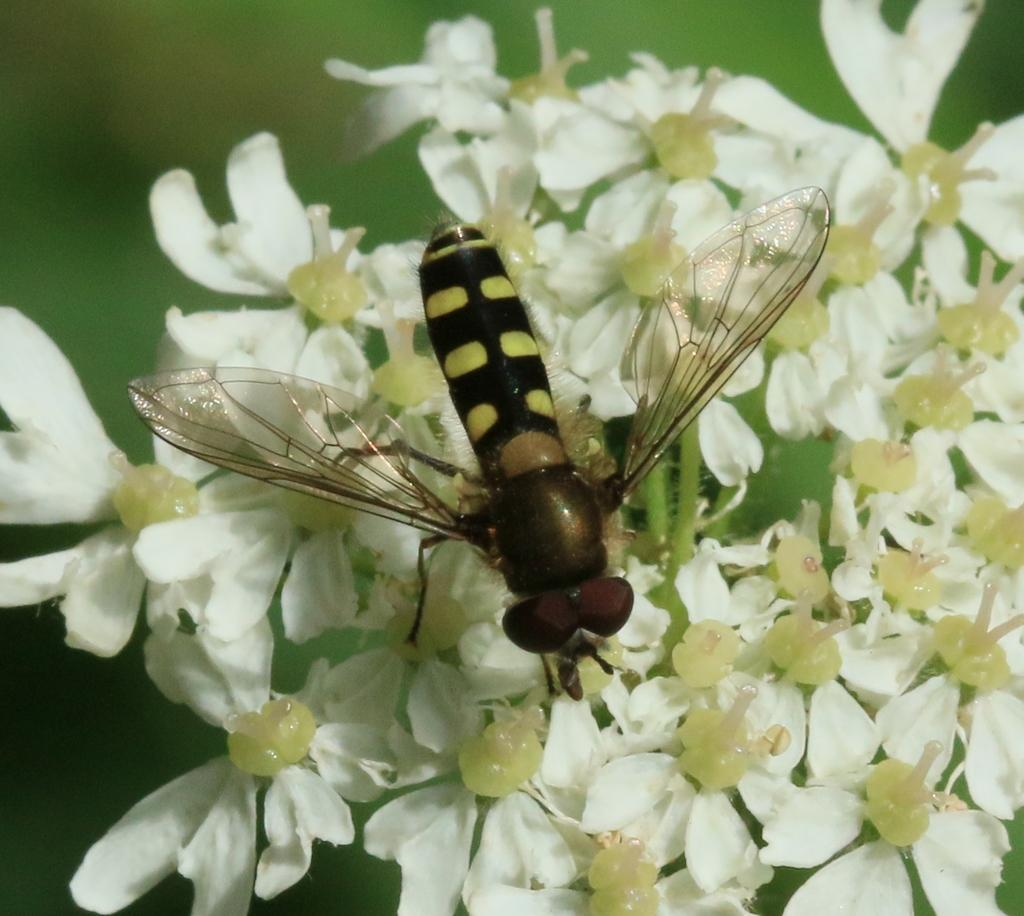What type of insect is present in the image? There is a bee in the picture. What can be seen in the image besides the bee? A: There are flowers in the picture. What channel is the ghost watching in the image? There is no ghost or television present in the image; it features a bee and flowers. 